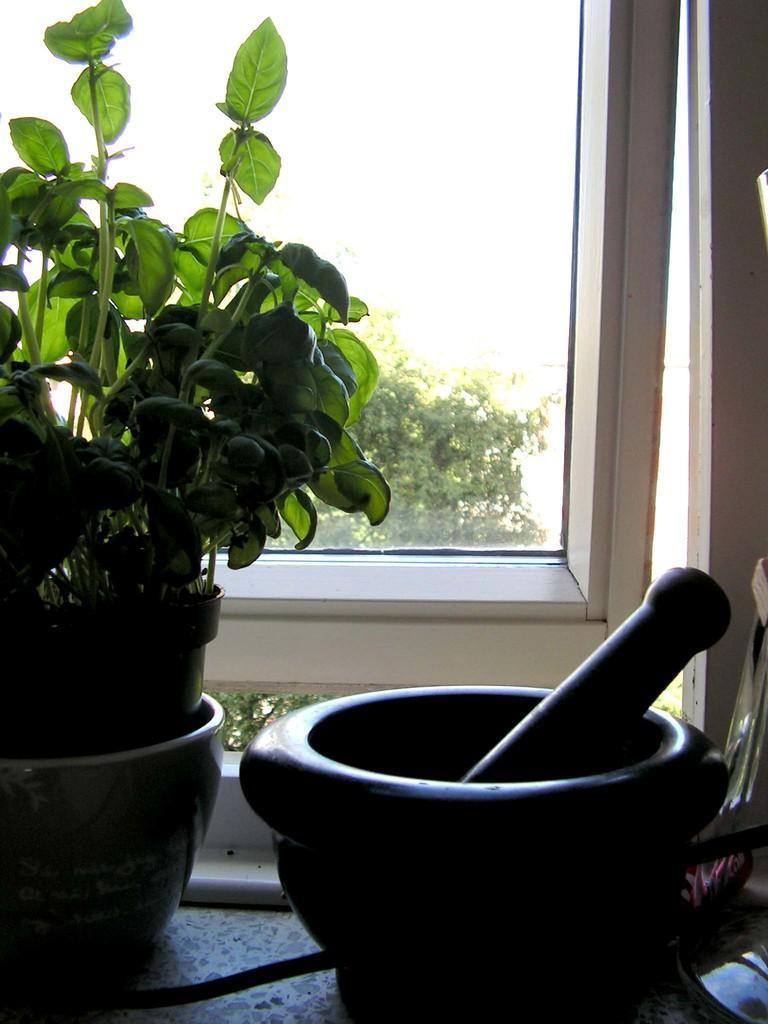Please provide a concise description of this image. In this image we can see a potted plant, window and a grinding stone, from the window we can see some trees and the sky. 